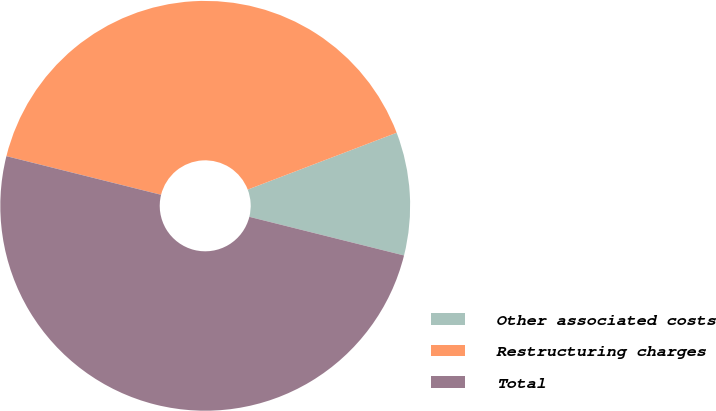Convert chart. <chart><loc_0><loc_0><loc_500><loc_500><pie_chart><fcel>Other associated costs<fcel>Restructuring charges<fcel>Total<nl><fcel>9.7%<fcel>40.3%<fcel>50.0%<nl></chart> 